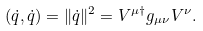Convert formula to latex. <formula><loc_0><loc_0><loc_500><loc_500>( \dot { q } , \dot { q } ) = \| \dot { q } \| ^ { 2 } = V ^ { \mu \dag } g _ { \mu \nu } V ^ { \nu } .</formula> 